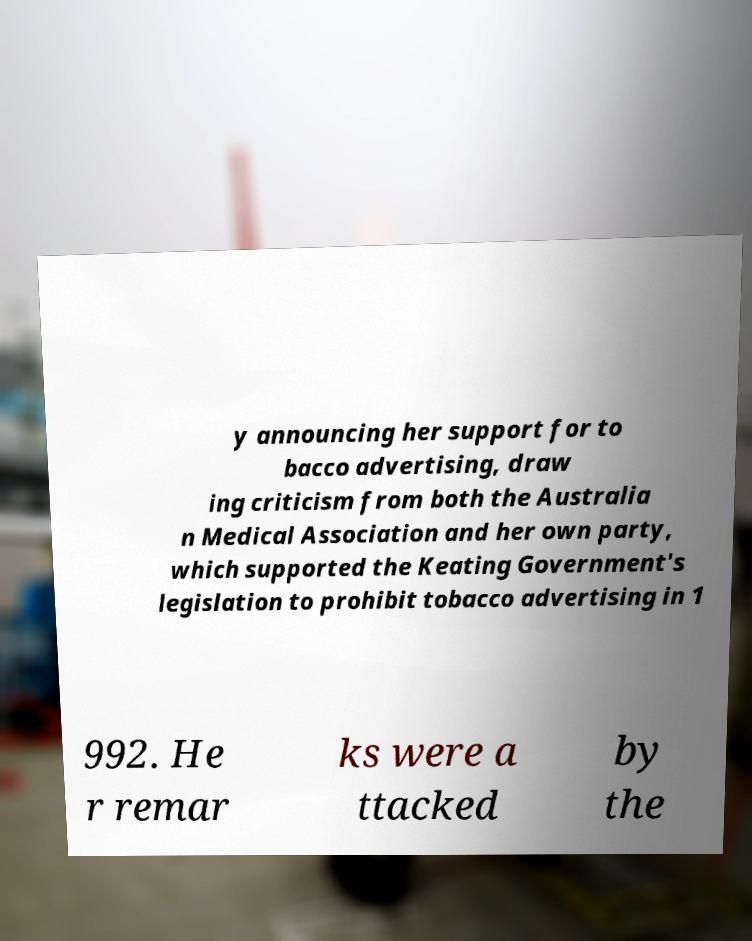Could you extract and type out the text from this image? y announcing her support for to bacco advertising, draw ing criticism from both the Australia n Medical Association and her own party, which supported the Keating Government's legislation to prohibit tobacco advertising in 1 992. He r remar ks were a ttacked by the 